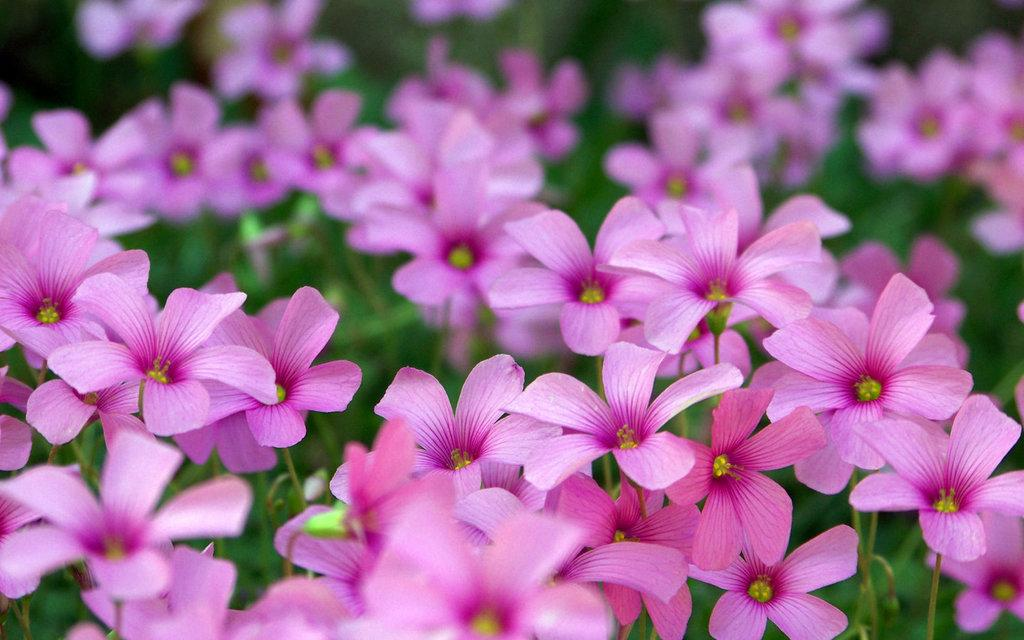What type of living organisms can be seen in the image? There are flowers in the image. Can you describe the background of the image? The background of the image is blurred. What type of authority figure can be seen in the image? There is no authority figure present in the image. What type of bubble can be seen in the image? There is no bubble present in the image. 